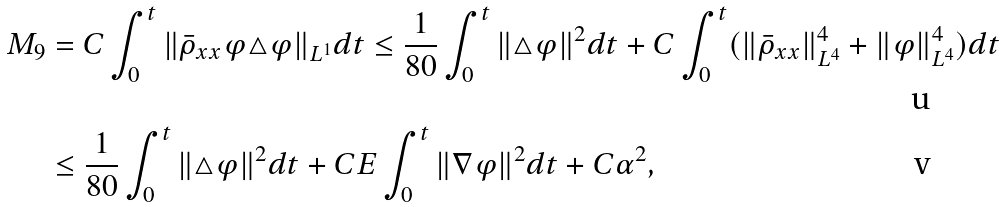<formula> <loc_0><loc_0><loc_500><loc_500>M _ { 9 } & = C \int _ { 0 } ^ { t } \| \bar { \rho } _ { x x } \varphi \triangle \varphi \| _ { L ^ { 1 } } d t \leq \frac { 1 } { 8 0 } \int _ { 0 } ^ { t } \| \triangle \varphi \| ^ { 2 } d t + C \int _ { 0 } ^ { t } ( \| \bar { \rho } _ { x x } \| _ { L ^ { 4 } } ^ { 4 } + \| \varphi \| _ { L ^ { 4 } } ^ { 4 } ) d t \\ & \leq \frac { 1 } { 8 0 } \int _ { 0 } ^ { t } \| \triangle \varphi \| ^ { 2 } d t + C E \int _ { 0 } ^ { t } \| \nabla \varphi \| ^ { 2 } d t + C \alpha ^ { 2 } ,</formula> 